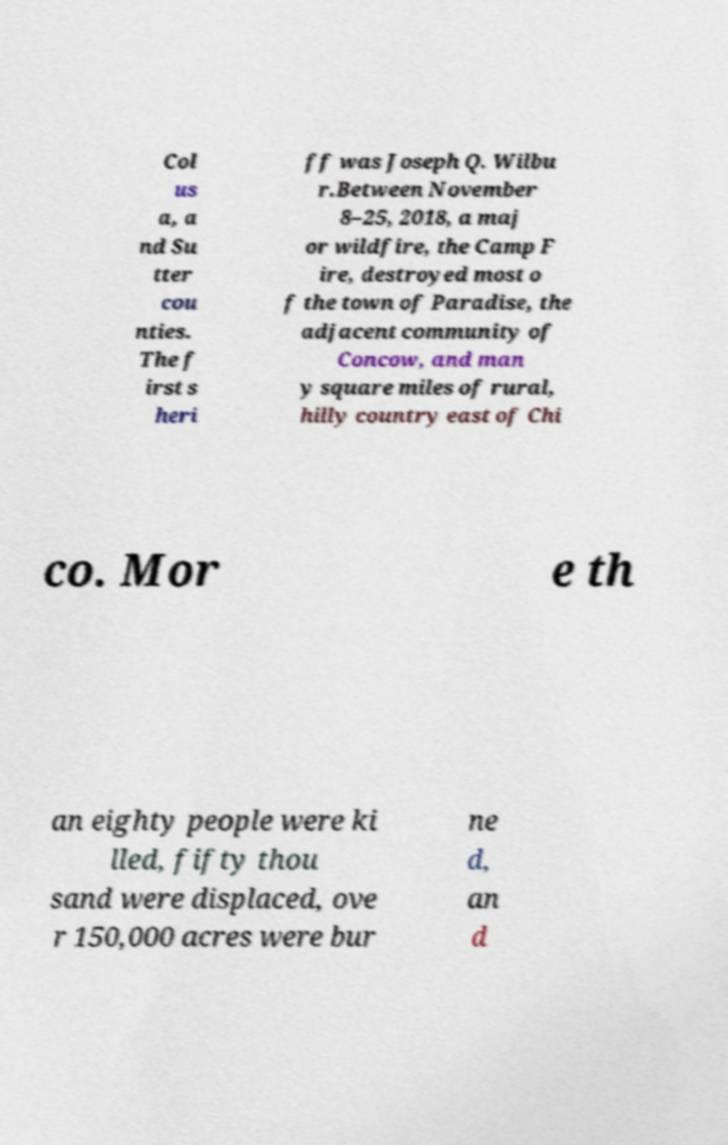Can you accurately transcribe the text from the provided image for me? Col us a, a nd Su tter cou nties. The f irst s heri ff was Joseph Q. Wilbu r.Between November 8–25, 2018, a maj or wildfire, the Camp F ire, destroyed most o f the town of Paradise, the adjacent community of Concow, and man y square miles of rural, hilly country east of Chi co. Mor e th an eighty people were ki lled, fifty thou sand were displaced, ove r 150,000 acres were bur ne d, an d 